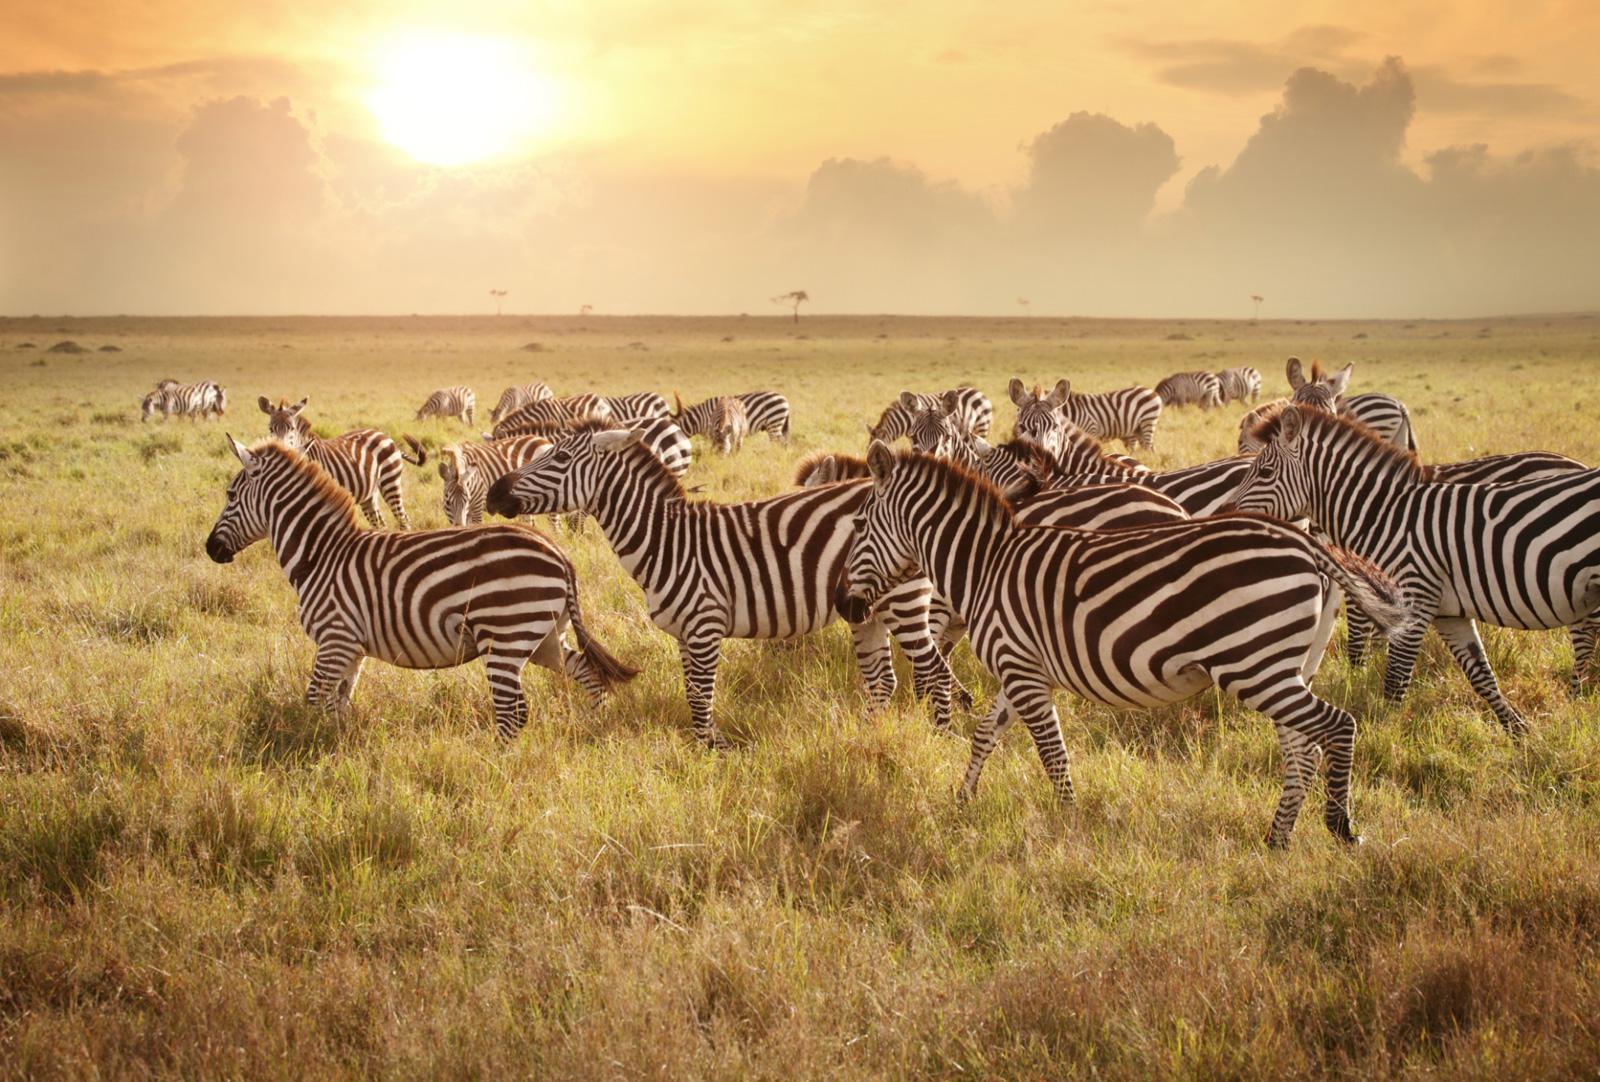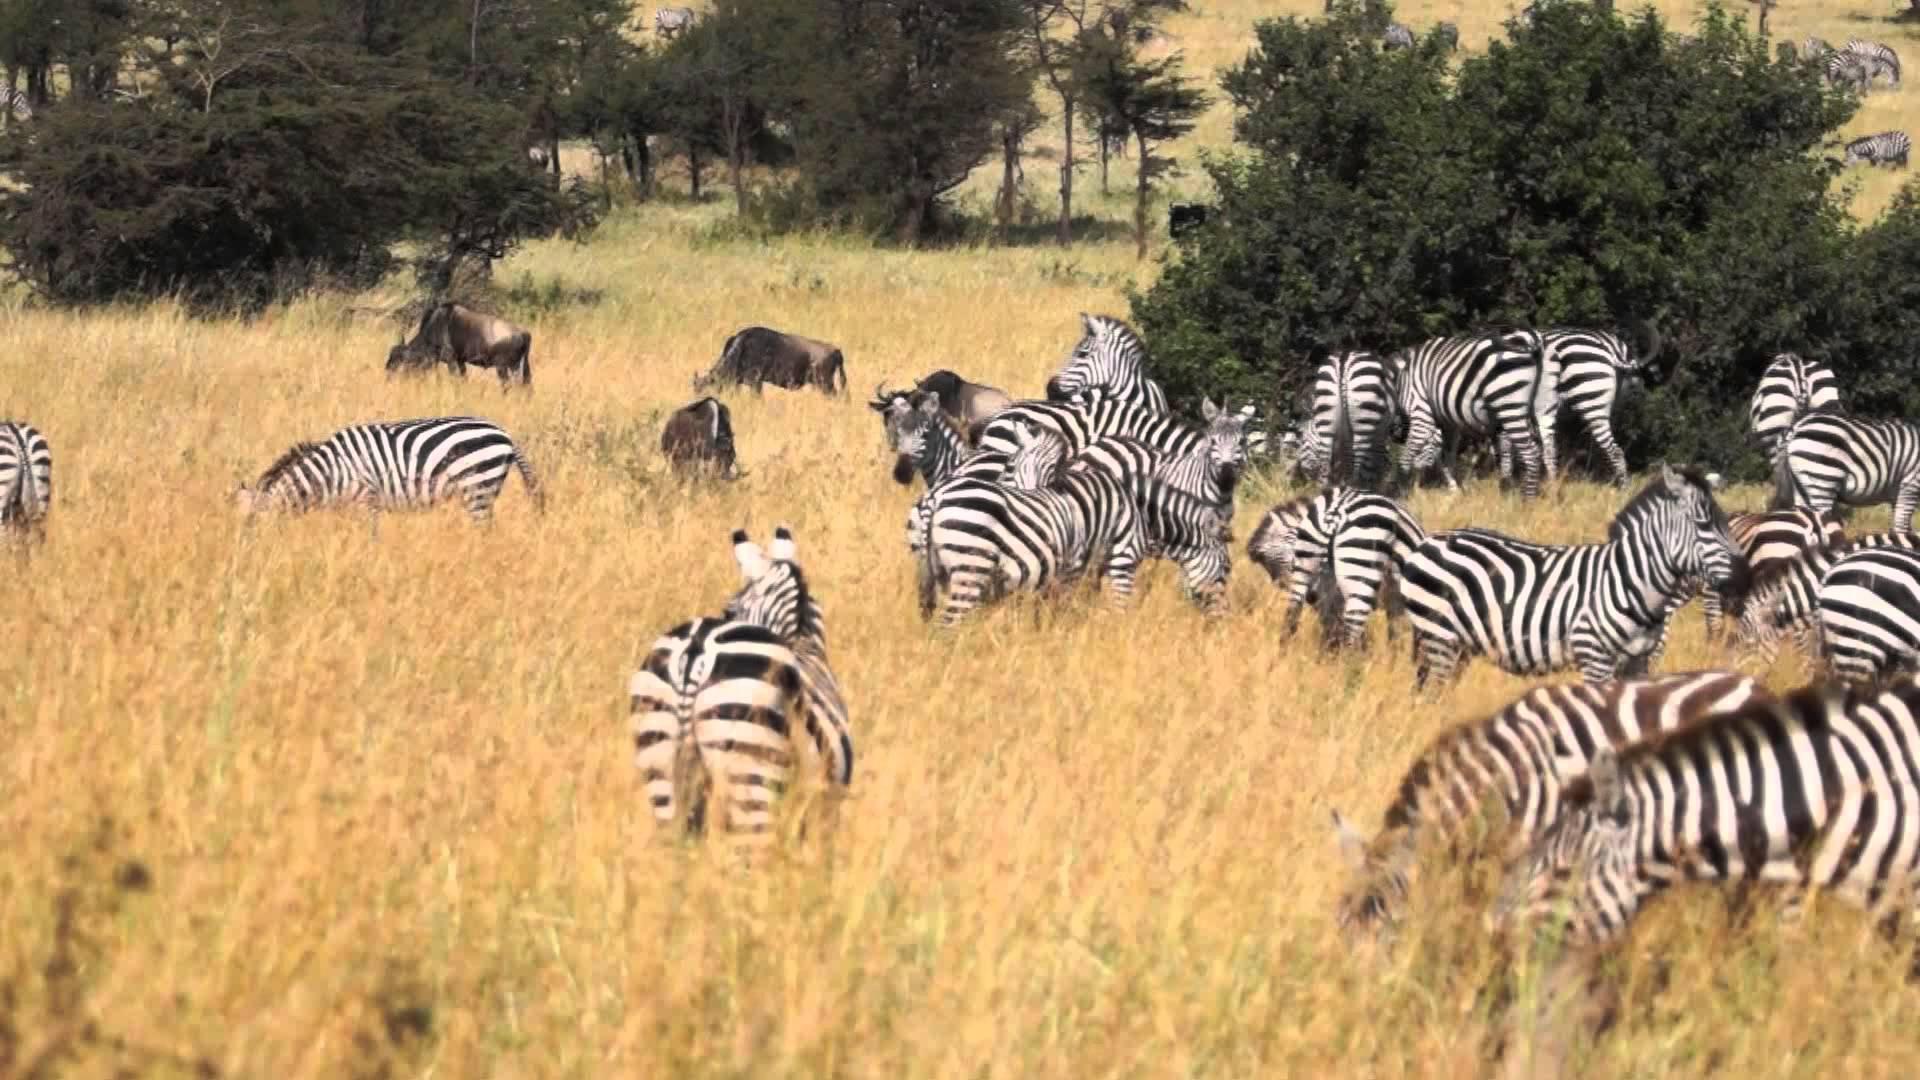The first image is the image on the left, the second image is the image on the right. Examine the images to the left and right. Is the description "The right image shows dark hooved animals grazing behind zebra, and the left image shows zebra in a field with no watering hole visible." accurate? Answer yes or no. Yes. The first image is the image on the left, the second image is the image on the right. Examine the images to the left and right. Is the description "There are clouds visible in the left image." accurate? Answer yes or no. Yes. 